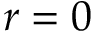<formula> <loc_0><loc_0><loc_500><loc_500>r = 0</formula> 